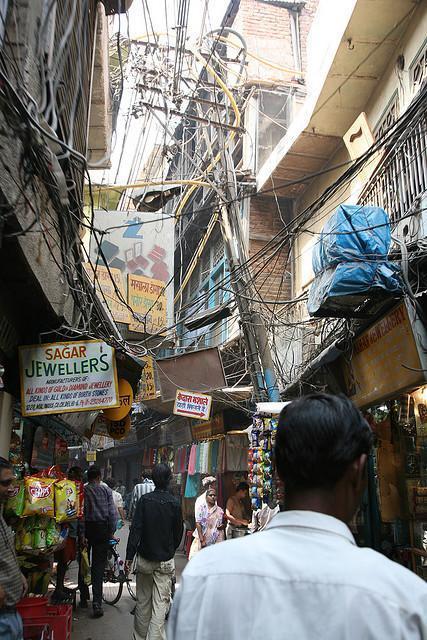How many people are there?
Give a very brief answer. 4. 